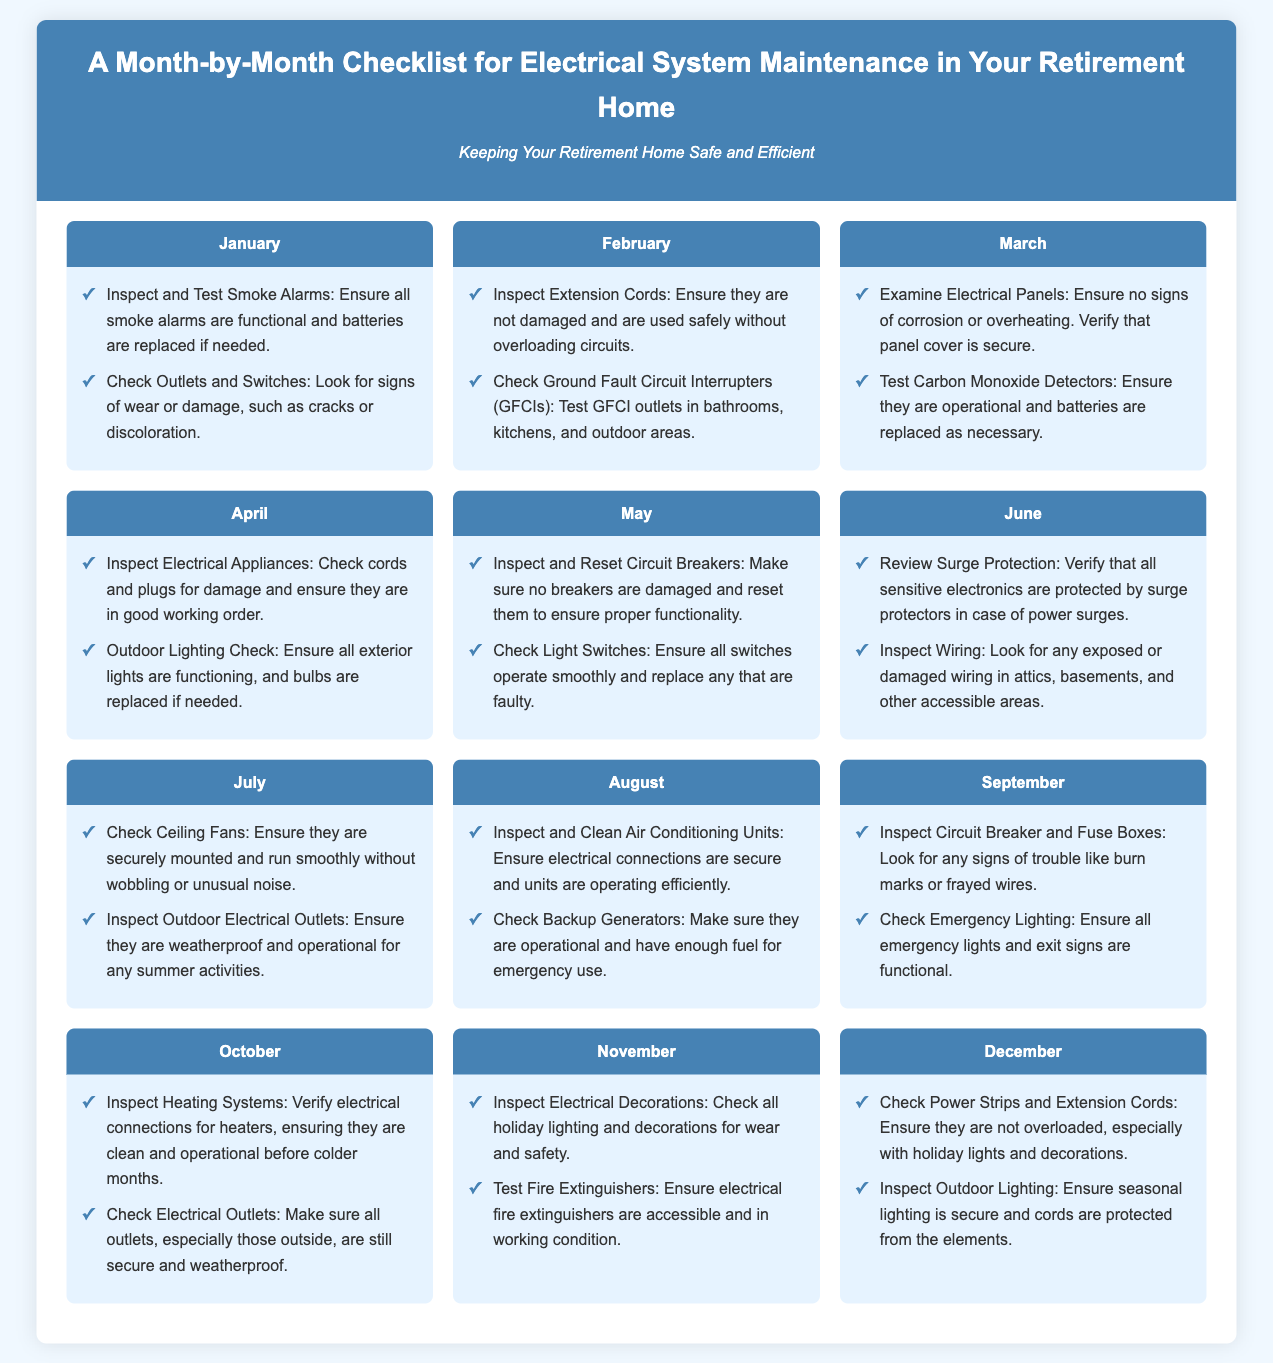What tasks should be performed in January? The tasks for January include inspecting and testing smoke alarms and checking outlets and switches.
Answer: Inspect and Test Smoke Alarms, Check Outlets and Switches How many tasks are listed for March? The document lists two tasks for March, which are to examine electrical panels and test carbon monoxide detectors.
Answer: 2 What is checked in June? In June, surge protection is reviewed and wiring is inspected.
Answer: Surge Protection, Wiring Which month includes inspecting electrical decorations? The month that includes inspecting electrical decorations is November.
Answer: November What type of outlets should be checked in October? Outdoor outlets should be checked in October to ensure they are secure and weatherproof.
Answer: Outdoor Outlets How many months have tasks related to checking electrical outlets? There are five months with tasks related to checking electrical outlets: January, February, September, October, and December.
Answer: 5 What is ensured in the August tasks? In August, air conditioning units are ensured to have secure electrical connections and be operational.
Answer: Air Conditioning Units What is the main goal of the checklist? The main goal of the checklist is to keep the retirement home safe and efficient.
Answer: Safe and Efficient Which month's tasks include examining electrical panels? The tasks for examining electrical panels are found in March.
Answer: March 